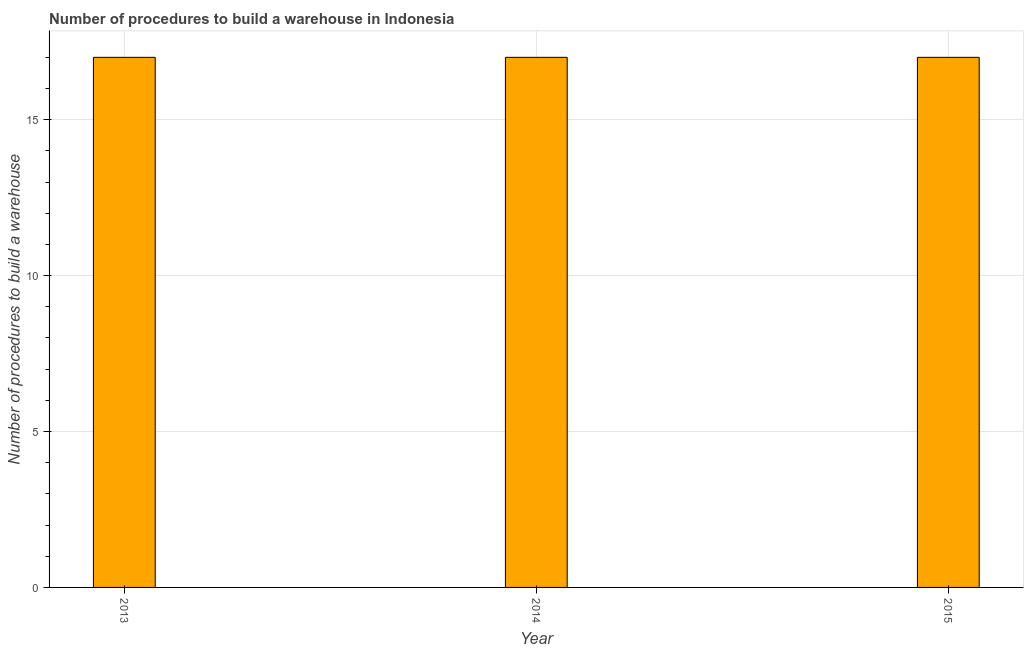Does the graph contain any zero values?
Your answer should be compact. No. What is the title of the graph?
Your answer should be very brief. Number of procedures to build a warehouse in Indonesia. What is the label or title of the Y-axis?
Make the answer very short. Number of procedures to build a warehouse. In which year was the number of procedures to build a warehouse maximum?
Provide a short and direct response. 2013. In which year was the number of procedures to build a warehouse minimum?
Make the answer very short. 2013. What is the average number of procedures to build a warehouse per year?
Your answer should be compact. 17. Do a majority of the years between 2014 and 2013 (inclusive) have number of procedures to build a warehouse greater than 9 ?
Keep it short and to the point. No. What is the ratio of the number of procedures to build a warehouse in 2013 to that in 2015?
Keep it short and to the point. 1. Is the sum of the number of procedures to build a warehouse in 2013 and 2014 greater than the maximum number of procedures to build a warehouse across all years?
Your answer should be compact. Yes. In how many years, is the number of procedures to build a warehouse greater than the average number of procedures to build a warehouse taken over all years?
Make the answer very short. 0. What is the Number of procedures to build a warehouse in 2013?
Provide a short and direct response. 17. What is the Number of procedures to build a warehouse of 2015?
Provide a succinct answer. 17. What is the difference between the Number of procedures to build a warehouse in 2013 and 2015?
Your answer should be very brief. 0. What is the difference between the Number of procedures to build a warehouse in 2014 and 2015?
Make the answer very short. 0. What is the ratio of the Number of procedures to build a warehouse in 2013 to that in 2014?
Offer a terse response. 1. What is the ratio of the Number of procedures to build a warehouse in 2013 to that in 2015?
Keep it short and to the point. 1. 